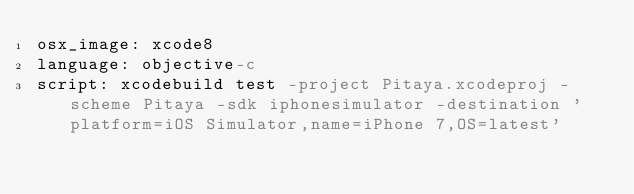Convert code to text. <code><loc_0><loc_0><loc_500><loc_500><_YAML_>osx_image: xcode8
language: objective-c
script: xcodebuild test -project Pitaya.xcodeproj -scheme Pitaya -sdk iphonesimulator -destination 'platform=iOS Simulator,name=iPhone 7,OS=latest'</code> 